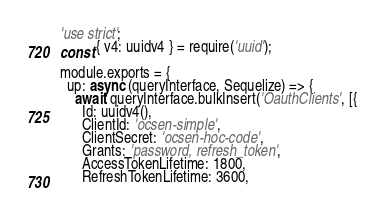<code> <loc_0><loc_0><loc_500><loc_500><_JavaScript_>'use strict';
const { v4: uuidv4 } = require('uuid');

module.exports = {
  up: async (queryInterface, Sequelize) => {
    await queryInterface.bulkInsert('OauthClients', [{
      Id: uuidv4(),
      ClientId: 'ocsen-simple',
      ClientSecret: 'ocsen-hoc-code',
      Grants: 'password, refresh_token',
      AccessTokenLifetime: 1800,
      RefreshTokenLifetime: 3600,</code> 